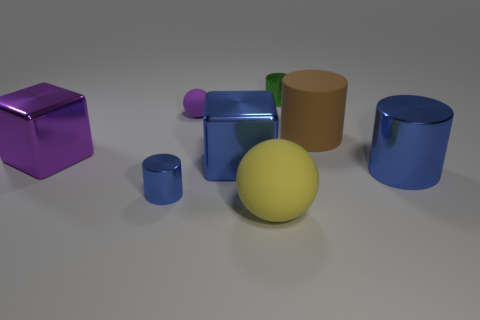Add 2 purple shiny blocks. How many objects exist? 10 Subtract all balls. How many objects are left? 6 Add 5 tiny blue things. How many tiny blue things exist? 6 Subtract 1 green cylinders. How many objects are left? 7 Subtract all small blue objects. Subtract all yellow objects. How many objects are left? 6 Add 8 large yellow matte things. How many large yellow matte things are left? 9 